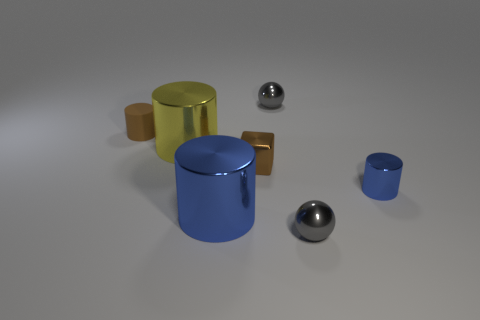Subtract 1 cylinders. How many cylinders are left? 3 Subtract all cyan cylinders. Subtract all cyan balls. How many cylinders are left? 4 Add 1 metal balls. How many objects exist? 8 Subtract all cylinders. How many objects are left? 3 Add 5 tiny metallic objects. How many tiny metallic objects exist? 9 Subtract 0 purple cubes. How many objects are left? 7 Subtract all tiny blue things. Subtract all large blue cylinders. How many objects are left? 5 Add 1 tiny metallic balls. How many tiny metallic balls are left? 3 